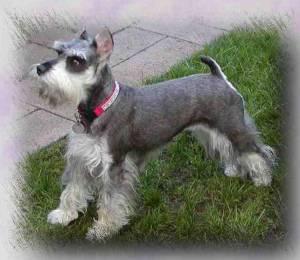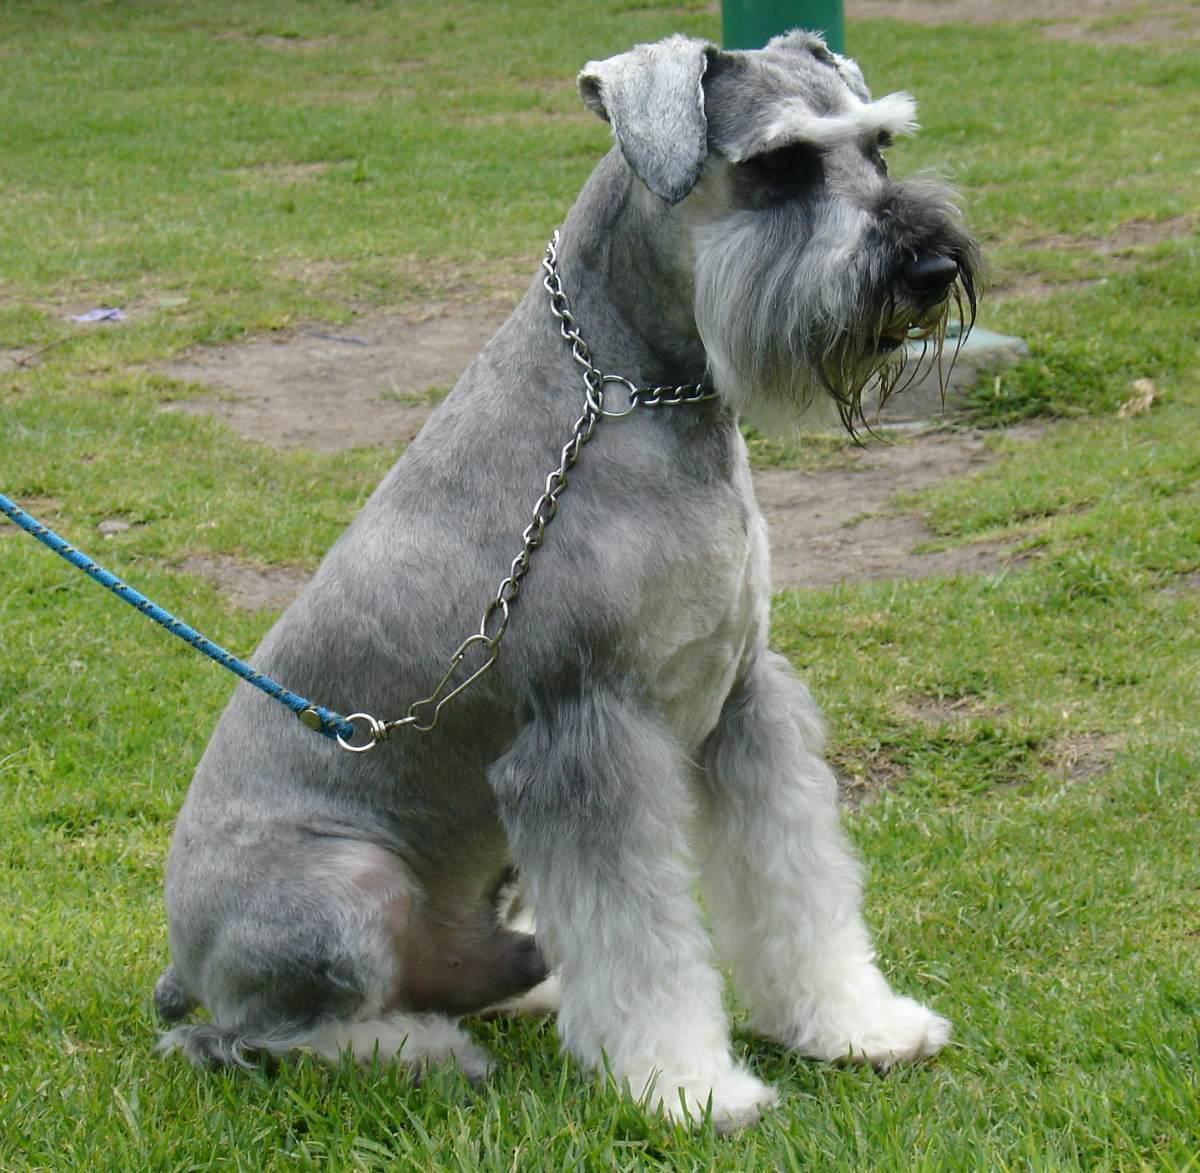The first image is the image on the left, the second image is the image on the right. For the images displayed, is the sentence "There is at least collar in the image on the left." factually correct? Answer yes or no. Yes. 